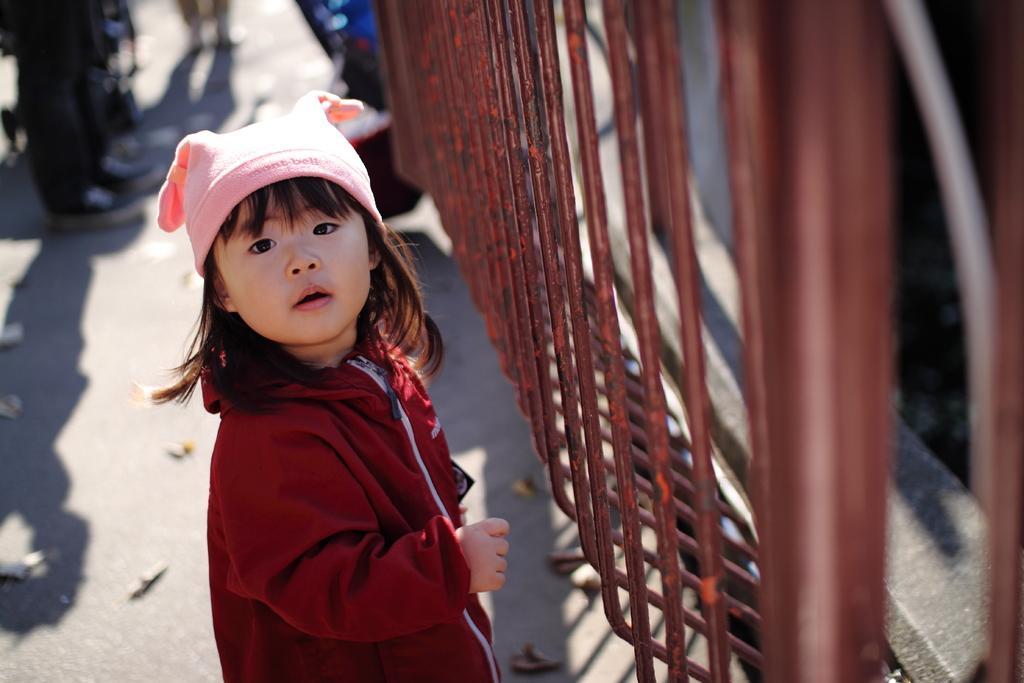How would you summarize this image in a sentence or two? In the center of the image we can see a girl standing. She is wearing a cap, before her there is a fence. In the background there are people. 